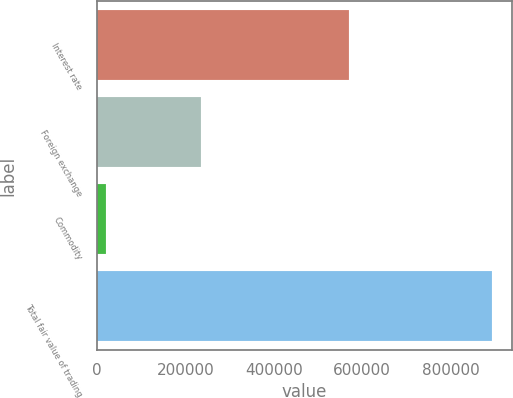Convert chart to OTSL. <chart><loc_0><loc_0><loc_500><loc_500><bar_chart><fcel>Interest rate<fcel>Foreign exchange<fcel>Commodity<fcel>Total fair value of trading<nl><fcel>570778<fcel>234971<fcel>20462<fcel>893239<nl></chart> 